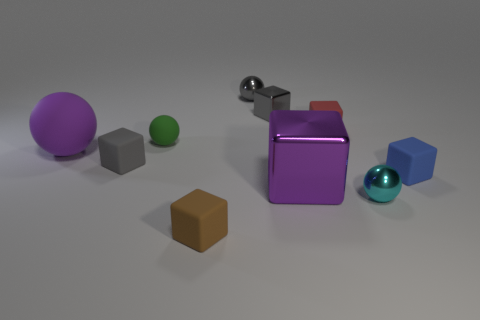Subtract 1 spheres. How many spheres are left? 3 Subtract all tiny gray matte blocks. How many blocks are left? 5 Subtract all red cubes. How many cubes are left? 5 Subtract all blue cubes. Subtract all cyan balls. How many cubes are left? 5 Subtract all blocks. How many objects are left? 4 Subtract 0 blue cylinders. How many objects are left? 10 Subtract all tiny metallic balls. Subtract all small blue blocks. How many objects are left? 7 Add 5 small blue objects. How many small blue objects are left? 6 Add 5 large blue rubber cylinders. How many large blue rubber cylinders exist? 5 